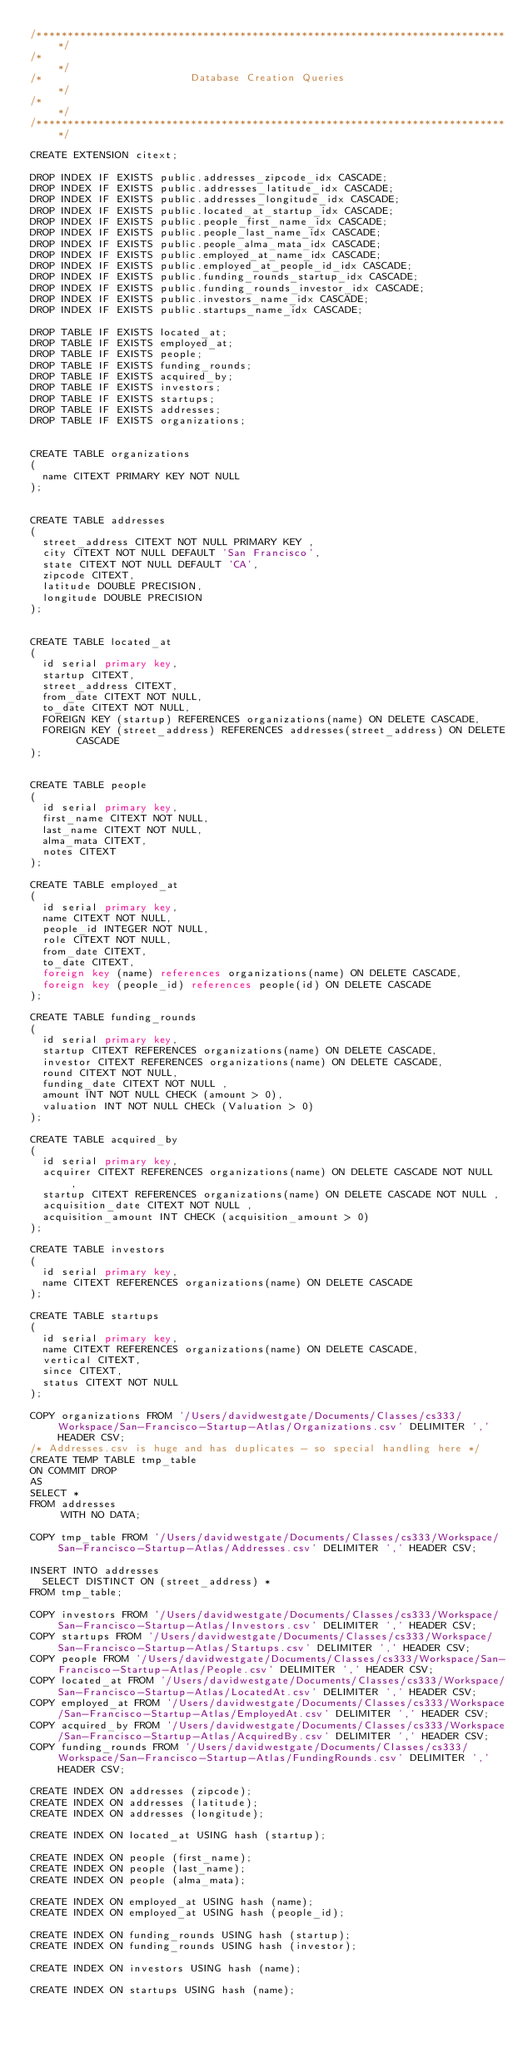<code> <loc_0><loc_0><loc_500><loc_500><_SQL_>/*****************************************************************************/
/*                                                                           */
/*                        Database Creation Queries                          */
/*                                                                           */
/*****************************************************************************/

CREATE EXTENSION citext;

DROP INDEX IF EXISTS public.addresses_zipcode_idx CASCADE;
DROP INDEX IF EXISTS public.addresses_latitude_idx CASCADE;
DROP INDEX IF EXISTS public.addresses_longitude_idx CASCADE;
DROP INDEX IF EXISTS public.located_at_startup_idx CASCADE;
DROP INDEX IF EXISTS public.people_first_name_idx CASCADE;
DROP INDEX IF EXISTS public.people_last_name_idx CASCADE;
DROP INDEX IF EXISTS public.people_alma_mata_idx CASCADE;
DROP INDEX IF EXISTS public.employed_at_name_idx CASCADE;
DROP INDEX IF EXISTS public.employed_at_people_id_idx CASCADE;
DROP INDEX IF EXISTS public.funding_rounds_startup_idx CASCADE;
DROP INDEX IF EXISTS public.funding_rounds_investor_idx CASCADE;
DROP INDEX IF EXISTS public.investors_name_idx CASCADE;
DROP INDEX IF EXISTS public.startups_name_idx CASCADE;

DROP TABLE IF EXISTS located_at;
DROP TABLE IF EXISTS employed_at;
DROP TABLE IF EXISTS people;
DROP TABLE IF EXISTS funding_rounds;
DROP TABLE IF EXISTS acquired_by;
DROP TABLE IF EXISTS investors;
DROP TABLE IF EXISTS startups;
DROP TABLE IF EXISTS addresses;
DROP TABLE IF EXISTS organizations;


CREATE TABLE organizations
(
  name CITEXT PRIMARY KEY NOT NULL
);


CREATE TABLE addresses
(
  street_address CITEXT NOT NULL PRIMARY KEY ,
  city CITEXT NOT NULL DEFAULT 'San Francisco',
  state CITEXT NOT NULL DEFAULT 'CA',
  zipcode CITEXT,
  latitude DOUBLE PRECISION,
  longitude DOUBLE PRECISION
);


CREATE TABLE located_at
(
  id serial primary key,
  startup CITEXT,
  street_address CITEXT,
  from_date CITEXT NOT NULL,
  to_date CITEXT NOT NULL,
  FOREIGN KEY (startup) REFERENCES organizations(name) ON DELETE CASCADE,
  FOREIGN KEY (street_address) REFERENCES addresses(street_address) ON DELETE CASCADE
);


CREATE TABLE people
(
  id serial primary key,
  first_name CITEXT NOT NULL,
  last_name CITEXT NOT NULL,
  alma_mata CITEXT,
  notes CITEXT
);

CREATE TABLE employed_at
(
  id serial primary key,
  name CITEXT NOT NULL,
  people_id INTEGER NOT NULL,
  role CITEXT NOT NULL,
  from_date CITEXT,
  to_date CITEXT,
  foreign key (name) references organizations(name) ON DELETE CASCADE,
  foreign key (people_id) references people(id) ON DELETE CASCADE
);

CREATE TABLE funding_rounds
(
  id serial primary key,
  startup CITEXT REFERENCES organizations(name) ON DELETE CASCADE,
  investor CITEXT REFERENCES organizations(name) ON DELETE CASCADE,
  round CITEXT NOT NULL,
  funding_date CITEXT NOT NULL ,
  amount INT NOT NULL CHECK (amount > 0),
  valuation INT NOT NULL CHECk (Valuation > 0)
);

CREATE TABLE acquired_by
(
  id serial primary key,
  acquirer CITEXT REFERENCES organizations(name) ON DELETE CASCADE NOT NULL  ,
  startup CITEXT REFERENCES organizations(name) ON DELETE CASCADE NOT NULL ,
  acquisition_date CITEXT NOT NULL ,
  acquisition_amount INT CHECK (acquisition_amount > 0)
);

CREATE TABLE investors
(
  id serial primary key,
  name CITEXT REFERENCES organizations(name) ON DELETE CASCADE
);

CREATE TABLE startups
(
  id serial primary key,
  name CITEXT REFERENCES organizations(name) ON DELETE CASCADE,
  vertical CITEXT,
  since CITEXT,
  status CITEXT NOT NULL
);

COPY organizations FROM '/Users/davidwestgate/Documents/Classes/cs333/Workspace/San-Francisco-Startup-Atlas/Organizations.csv' DELIMITER ',' HEADER CSV;
/* Addresses.csv is huge and has duplicates - so special handling here */
CREATE TEMP TABLE tmp_table
ON COMMIT DROP
AS
SELECT *
FROM addresses
     WITH NO DATA;

COPY tmp_table FROM '/Users/davidwestgate/Documents/Classes/cs333/Workspace/San-Francisco-Startup-Atlas/Addresses.csv' DELIMITER ',' HEADER CSV;

INSERT INTO addresses
  SELECT DISTINCT ON (street_address) *
FROM tmp_table;

COPY investors FROM '/Users/davidwestgate/Documents/Classes/cs333/Workspace/San-Francisco-Startup-Atlas/Investors.csv' DELIMITER ',' HEADER CSV;
COPY startups FROM '/Users/davidwestgate/Documents/Classes/cs333/Workspace/San-Francisco-Startup-Atlas/Startups.csv' DELIMITER ',' HEADER CSV;
COPY people FROM '/Users/davidwestgate/Documents/Classes/cs333/Workspace/San-Francisco-Startup-Atlas/People.csv' DELIMITER ',' HEADER CSV;
COPY located_at FROM '/Users/davidwestgate/Documents/Classes/cs333/Workspace/San-Francisco-Startup-Atlas/LocatedAt.csv' DELIMITER ',' HEADER CSV;
COPY employed_at FROM '/Users/davidwestgate/Documents/Classes/cs333/Workspace/San-Francisco-Startup-Atlas/EmployedAt.csv' DELIMITER ',' HEADER CSV;
COPY acquired_by FROM '/Users/davidwestgate/Documents/Classes/cs333/Workspace/San-Francisco-Startup-Atlas/AcquiredBy.csv' DELIMITER ',' HEADER CSV;
COPY funding_rounds FROM '/Users/davidwestgate/Documents/Classes/cs333/Workspace/San-Francisco-Startup-Atlas/FundingRounds.csv' DELIMITER ',' HEADER CSV;

CREATE INDEX ON addresses (zipcode);
CREATE INDEX ON addresses (latitude);
CREATE INDEX ON addresses (longitude);

CREATE INDEX ON located_at USING hash (startup);

CREATE INDEX ON people (first_name);
CREATE INDEX ON people (last_name);
CREATE INDEX ON people (alma_mata);

CREATE INDEX ON employed_at USING hash (name);
CREATE INDEX ON employed_at USING hash (people_id);

CREATE INDEX ON funding_rounds USING hash (startup);
CREATE INDEX ON funding_rounds USING hash (investor);

CREATE INDEX ON investors USING hash (name);

CREATE INDEX ON startups USING hash (name);
</code> 